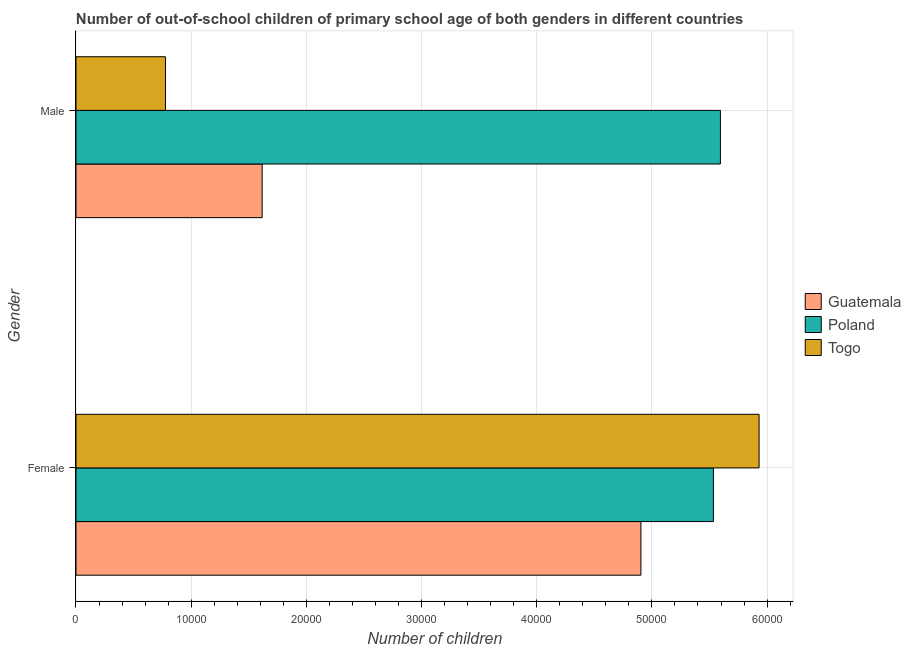How many groups of bars are there?
Offer a terse response. 2. How many bars are there on the 1st tick from the bottom?
Make the answer very short. 3. What is the number of male out-of-school students in Guatemala?
Ensure brevity in your answer.  1.62e+04. Across all countries, what is the maximum number of male out-of-school students?
Provide a succinct answer. 5.59e+04. Across all countries, what is the minimum number of male out-of-school students?
Your answer should be compact. 7767. In which country was the number of female out-of-school students maximum?
Your answer should be compact. Togo. In which country was the number of male out-of-school students minimum?
Provide a succinct answer. Togo. What is the total number of female out-of-school students in the graph?
Make the answer very short. 1.64e+05. What is the difference between the number of female out-of-school students in Guatemala and that in Togo?
Offer a very short reply. -1.03e+04. What is the difference between the number of female out-of-school students in Togo and the number of male out-of-school students in Poland?
Provide a succinct answer. 3357. What is the average number of male out-of-school students per country?
Your response must be concise. 2.66e+04. What is the difference between the number of female out-of-school students and number of male out-of-school students in Poland?
Make the answer very short. -608. What is the ratio of the number of male out-of-school students in Guatemala to that in Poland?
Provide a short and direct response. 0.29. Is the number of male out-of-school students in Togo less than that in Poland?
Provide a short and direct response. Yes. What does the 3rd bar from the bottom in Female represents?
Your answer should be very brief. Togo. How many bars are there?
Your response must be concise. 6. Does the graph contain any zero values?
Keep it short and to the point. No. How are the legend labels stacked?
Your response must be concise. Vertical. What is the title of the graph?
Your answer should be very brief. Number of out-of-school children of primary school age of both genders in different countries. What is the label or title of the X-axis?
Your answer should be compact. Number of children. What is the label or title of the Y-axis?
Make the answer very short. Gender. What is the Number of children in Guatemala in Female?
Provide a short and direct response. 4.90e+04. What is the Number of children of Poland in Female?
Your answer should be very brief. 5.53e+04. What is the Number of children of Togo in Female?
Give a very brief answer. 5.93e+04. What is the Number of children in Guatemala in Male?
Give a very brief answer. 1.62e+04. What is the Number of children of Poland in Male?
Ensure brevity in your answer.  5.59e+04. What is the Number of children of Togo in Male?
Offer a very short reply. 7767. Across all Gender, what is the maximum Number of children in Guatemala?
Your answer should be compact. 4.90e+04. Across all Gender, what is the maximum Number of children of Poland?
Keep it short and to the point. 5.59e+04. Across all Gender, what is the maximum Number of children in Togo?
Your response must be concise. 5.93e+04. Across all Gender, what is the minimum Number of children of Guatemala?
Provide a succinct answer. 1.62e+04. Across all Gender, what is the minimum Number of children of Poland?
Your answer should be very brief. 5.53e+04. Across all Gender, what is the minimum Number of children in Togo?
Keep it short and to the point. 7767. What is the total Number of children in Guatemala in the graph?
Keep it short and to the point. 6.52e+04. What is the total Number of children of Poland in the graph?
Offer a terse response. 1.11e+05. What is the total Number of children of Togo in the graph?
Offer a very short reply. 6.71e+04. What is the difference between the Number of children in Guatemala in Female and that in Male?
Your answer should be compact. 3.29e+04. What is the difference between the Number of children of Poland in Female and that in Male?
Offer a terse response. -608. What is the difference between the Number of children in Togo in Female and that in Male?
Your response must be concise. 5.15e+04. What is the difference between the Number of children of Guatemala in Female and the Number of children of Poland in Male?
Your answer should be compact. -6902. What is the difference between the Number of children in Guatemala in Female and the Number of children in Togo in Male?
Offer a terse response. 4.13e+04. What is the difference between the Number of children in Poland in Female and the Number of children in Togo in Male?
Ensure brevity in your answer.  4.76e+04. What is the average Number of children of Guatemala per Gender?
Ensure brevity in your answer.  3.26e+04. What is the average Number of children in Poland per Gender?
Your response must be concise. 5.56e+04. What is the average Number of children in Togo per Gender?
Give a very brief answer. 3.35e+04. What is the difference between the Number of children in Guatemala and Number of children in Poland in Female?
Give a very brief answer. -6294. What is the difference between the Number of children in Guatemala and Number of children in Togo in Female?
Provide a succinct answer. -1.03e+04. What is the difference between the Number of children of Poland and Number of children of Togo in Female?
Offer a terse response. -3965. What is the difference between the Number of children in Guatemala and Number of children in Poland in Male?
Provide a short and direct response. -3.98e+04. What is the difference between the Number of children in Guatemala and Number of children in Togo in Male?
Make the answer very short. 8395. What is the difference between the Number of children of Poland and Number of children of Togo in Male?
Your answer should be compact. 4.82e+04. What is the ratio of the Number of children of Guatemala in Female to that in Male?
Offer a very short reply. 3.03. What is the ratio of the Number of children in Poland in Female to that in Male?
Your response must be concise. 0.99. What is the ratio of the Number of children in Togo in Female to that in Male?
Provide a succinct answer. 7.64. What is the difference between the highest and the second highest Number of children in Guatemala?
Give a very brief answer. 3.29e+04. What is the difference between the highest and the second highest Number of children in Poland?
Make the answer very short. 608. What is the difference between the highest and the second highest Number of children in Togo?
Ensure brevity in your answer.  5.15e+04. What is the difference between the highest and the lowest Number of children in Guatemala?
Offer a terse response. 3.29e+04. What is the difference between the highest and the lowest Number of children of Poland?
Provide a short and direct response. 608. What is the difference between the highest and the lowest Number of children of Togo?
Keep it short and to the point. 5.15e+04. 